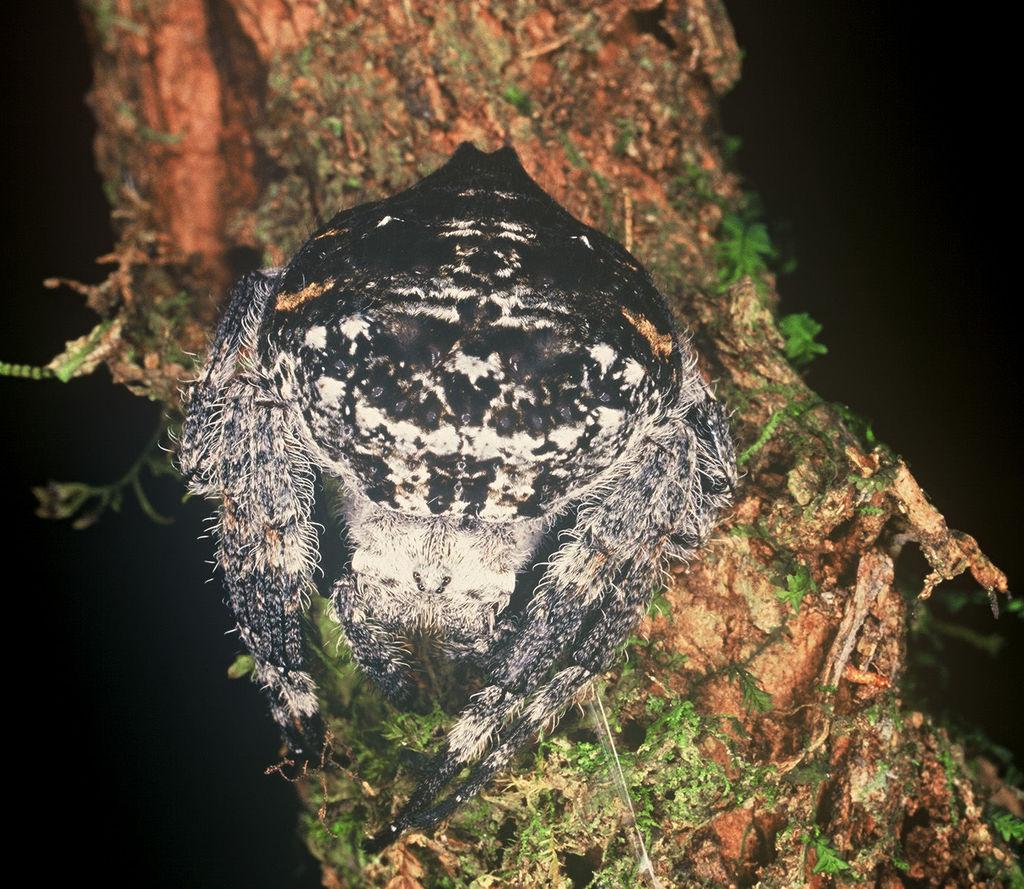What type of creature can be seen in the image? There is an insect in the image. Where is the insect located? The insect is on a tree. What type of shirt is the insect wearing in the image? There is no shirt present in the image, as insects do not wear clothing. 